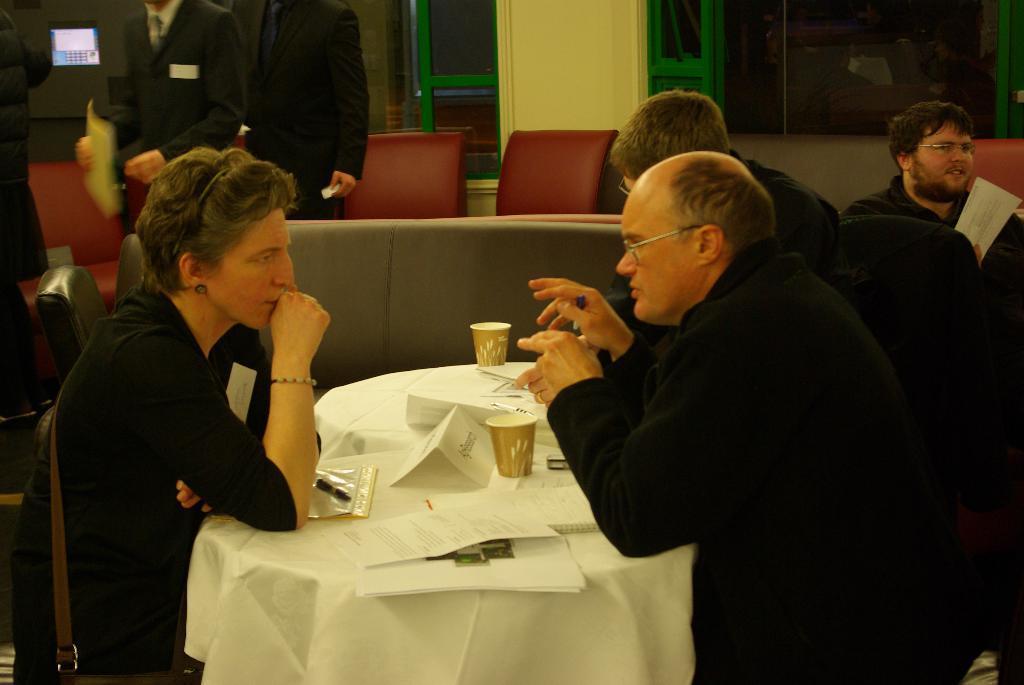Please provide a concise description of this image. In this image i can see three person sitting on chair, there are two cups, plate on a table at the back ground ii can see the other person sitting a wall, and a window. 